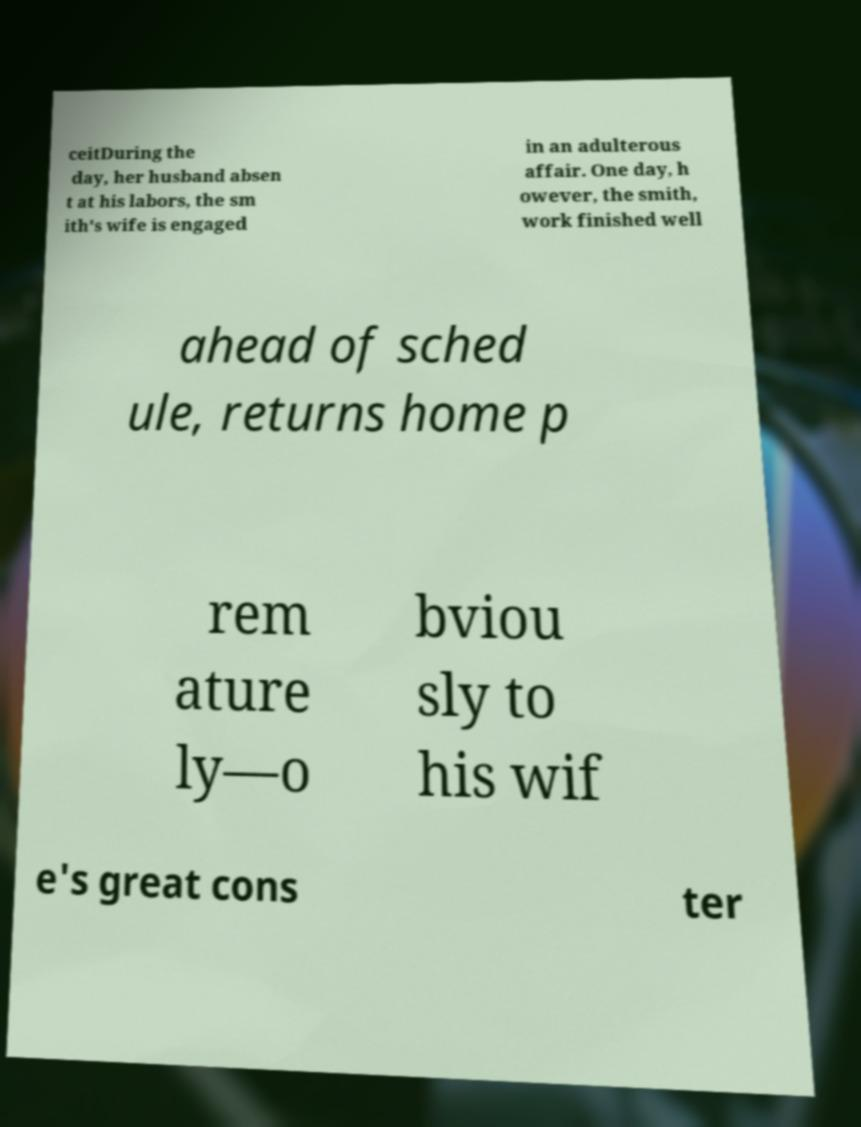Can you read and provide the text displayed in the image?This photo seems to have some interesting text. Can you extract and type it out for me? ceitDuring the day, her husband absen t at his labors, the sm ith's wife is engaged in an adulterous affair. One day, h owever, the smith, work finished well ahead of sched ule, returns home p rem ature ly—o bviou sly to his wif e's great cons ter 